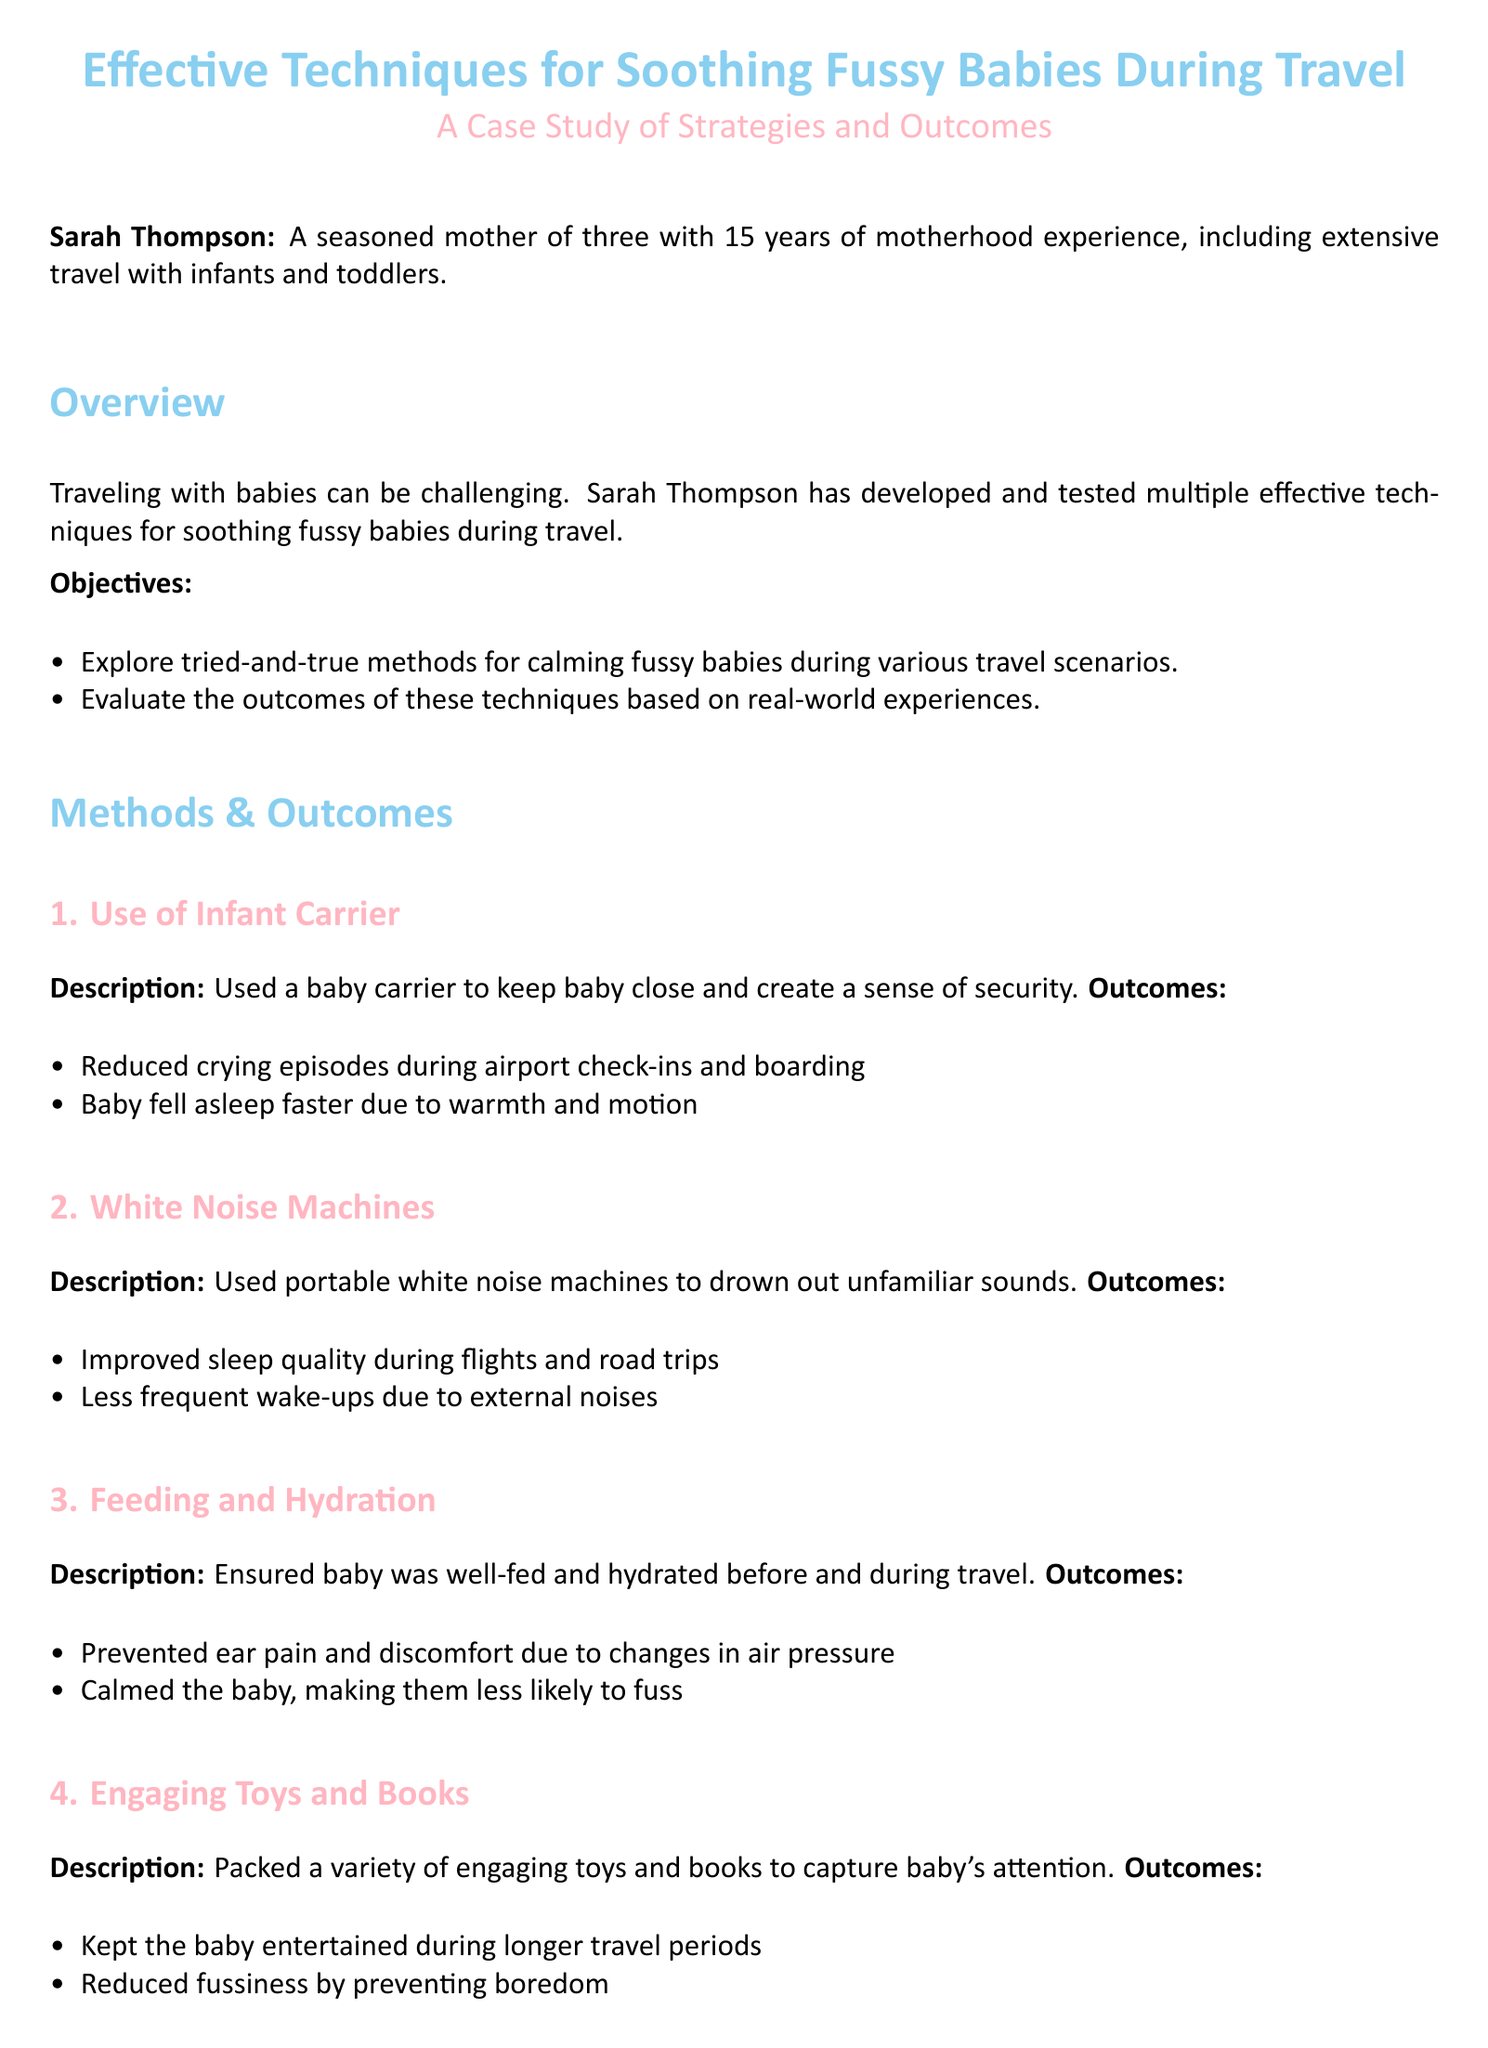What is the title of the case study? The title of the case study is prominently displayed at the beginning, which is "Effective Techniques for Soothing Fussy Babies During Travel."
Answer: Effective Techniques for Soothing Fussy Babies During Travel Who conducted the case study? The document indicates that Sarah Thompson is the individual who conducted the case study and it mentions her experience.
Answer: Sarah Thompson What is one technique used for soothing fussy babies during travel? The document lists several techniques, one of which is the use of an infant carrier.
Answer: Use of Infant Carrier How many years of motherhood experience does Sarah Thompson have? The document states that Sarah Thompson has 15 years of experience in motherhood.
Answer: 15 years What are the documented outcomes of using white noise machines? The case study outlines that white noise machines improved sleep quality during flights and road trips, among other benefits.
Answer: Improved sleep quality during flights and road trips What is the recommended preparation for parents? The recommendations section encourages parents to prepare and test different soothing techniques for their baby.
Answer: Prepare and test different soothing techniques What is the frequency of scheduled breaks during road trips? The document indicates that scheduled breaks should be regular and aligned with the baby's schedule.
Answer: Regular stops aligned with baby's schedule What two qualities are essential for parents according to the recommendations? The recommendations state that parents should stay flexible and patient when soothing their babies.
Answer: Flexible and patient What childhood experience does Sarah Thompson focus on in her case study? The document suggests the focus is on strategies for soothing fussy babies during travel.
Answer: Soothing fussy babies during travel 